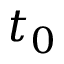Convert formula to latex. <formula><loc_0><loc_0><loc_500><loc_500>t _ { 0 }</formula> 